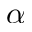Convert formula to latex. <formula><loc_0><loc_0><loc_500><loc_500>\alpha</formula> 